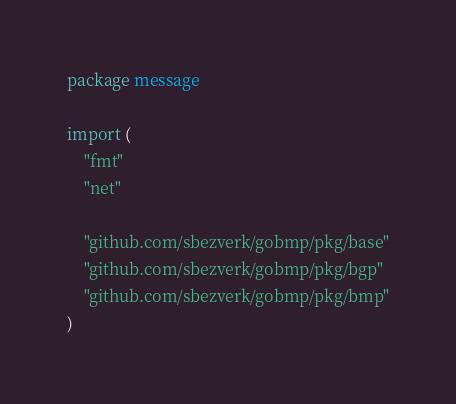Convert code to text. <code><loc_0><loc_0><loc_500><loc_500><_Go_>package message

import (
	"fmt"
	"net"

	"github.com/sbezverk/gobmp/pkg/base"
	"github.com/sbezverk/gobmp/pkg/bgp"
	"github.com/sbezverk/gobmp/pkg/bmp"
)
</code> 